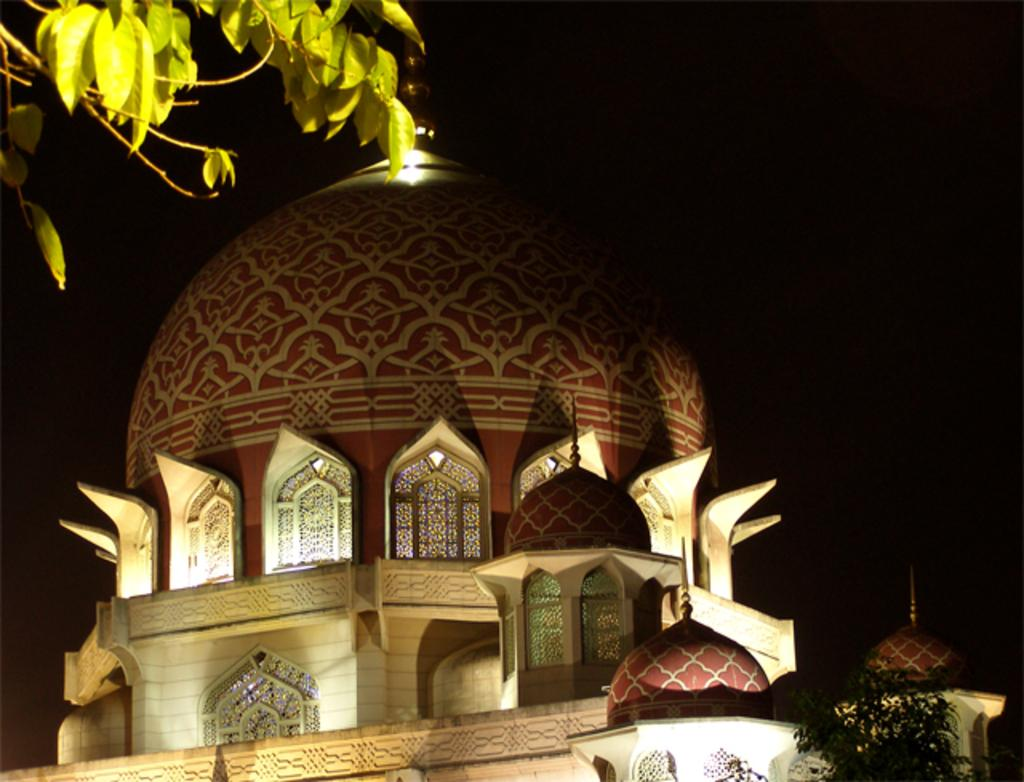What type of building is shown in the image? The image appears to depict a mosque. Can you describe any additional details about the image? There are leaves visible in the left top corner of the image. How many angles can be seen in the image? There is no specific mention of angles in the image, so it is not possible to determine the number of angles present. 